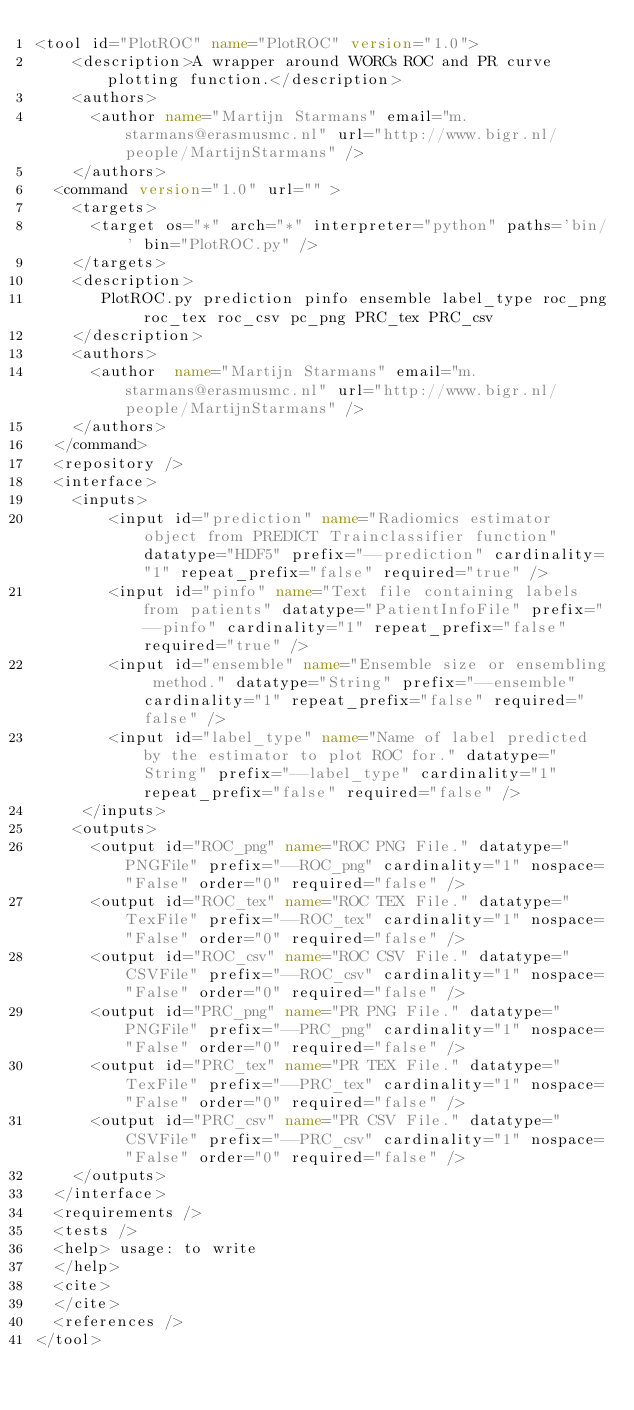<code> <loc_0><loc_0><loc_500><loc_500><_XML_><tool id="PlotROC" name="PlotROC" version="1.0">
    <description>A wrapper around WORCs ROC and PR curve plotting function.</description>
    <authors>
      <author name="Martijn Starmans" email="m.starmans@erasmusmc.nl" url="http://www.bigr.nl/people/MartijnStarmans" />
    </authors>
  <command version="1.0" url="" >
    <targets>
      <target os="*" arch="*" interpreter="python" paths='bin/' bin="PlotROC.py" />
    </targets>
    <description>
       PlotROC.py prediction pinfo ensemble label_type roc_png roc_tex roc_csv pc_png PRC_tex PRC_csv
    </description>
    <authors>
      <author  name="Martijn Starmans" email="m.starmans@erasmusmc.nl" url="http://www.bigr.nl/people/MartijnStarmans" />
    </authors>
  </command>
  <repository />
  <interface>
    <inputs>
        <input id="prediction" name="Radiomics estimator object from PREDICT Trainclassifier function" datatype="HDF5" prefix="--prediction" cardinality="1" repeat_prefix="false" required="true" />
        <input id="pinfo" name="Text file containing labels from patients" datatype="PatientInfoFile" prefix="--pinfo" cardinality="1" repeat_prefix="false" required="true" />
        <input id="ensemble" name="Ensemble size or ensembling method." datatype="String" prefix="--ensemble" cardinality="1" repeat_prefix="false" required="false" />
        <input id="label_type" name="Name of label predicted by the estimator to plot ROC for." datatype="String" prefix="--label_type" cardinality="1" repeat_prefix="false" required="false" />
     </inputs>
    <outputs>
      <output id="ROC_png" name="ROC PNG File." datatype="PNGFile" prefix="--ROC_png" cardinality="1" nospace="False" order="0" required="false" />
      <output id="ROC_tex" name="ROC TEX File." datatype="TexFile" prefix="--ROC_tex" cardinality="1" nospace="False" order="0" required="false" />
      <output id="ROC_csv" name="ROC CSV File." datatype="CSVFile" prefix="--ROC_csv" cardinality="1" nospace="False" order="0" required="false" />
      <output id="PRC_png" name="PR PNG File." datatype="PNGFile" prefix="--PRC_png" cardinality="1" nospace="False" order="0" required="false" />
      <output id="PRC_tex" name="PR TEX File." datatype="TexFile" prefix="--PRC_tex" cardinality="1" nospace="False" order="0" required="false" />
      <output id="PRC_csv" name="PR CSV File." datatype="CSVFile" prefix="--PRC_csv" cardinality="1" nospace="False" order="0" required="false" />
    </outputs>
  </interface>
  <requirements />
  <tests />
  <help> usage: to write
  </help>
  <cite>
  </cite>
  <references />
</tool>
</code> 